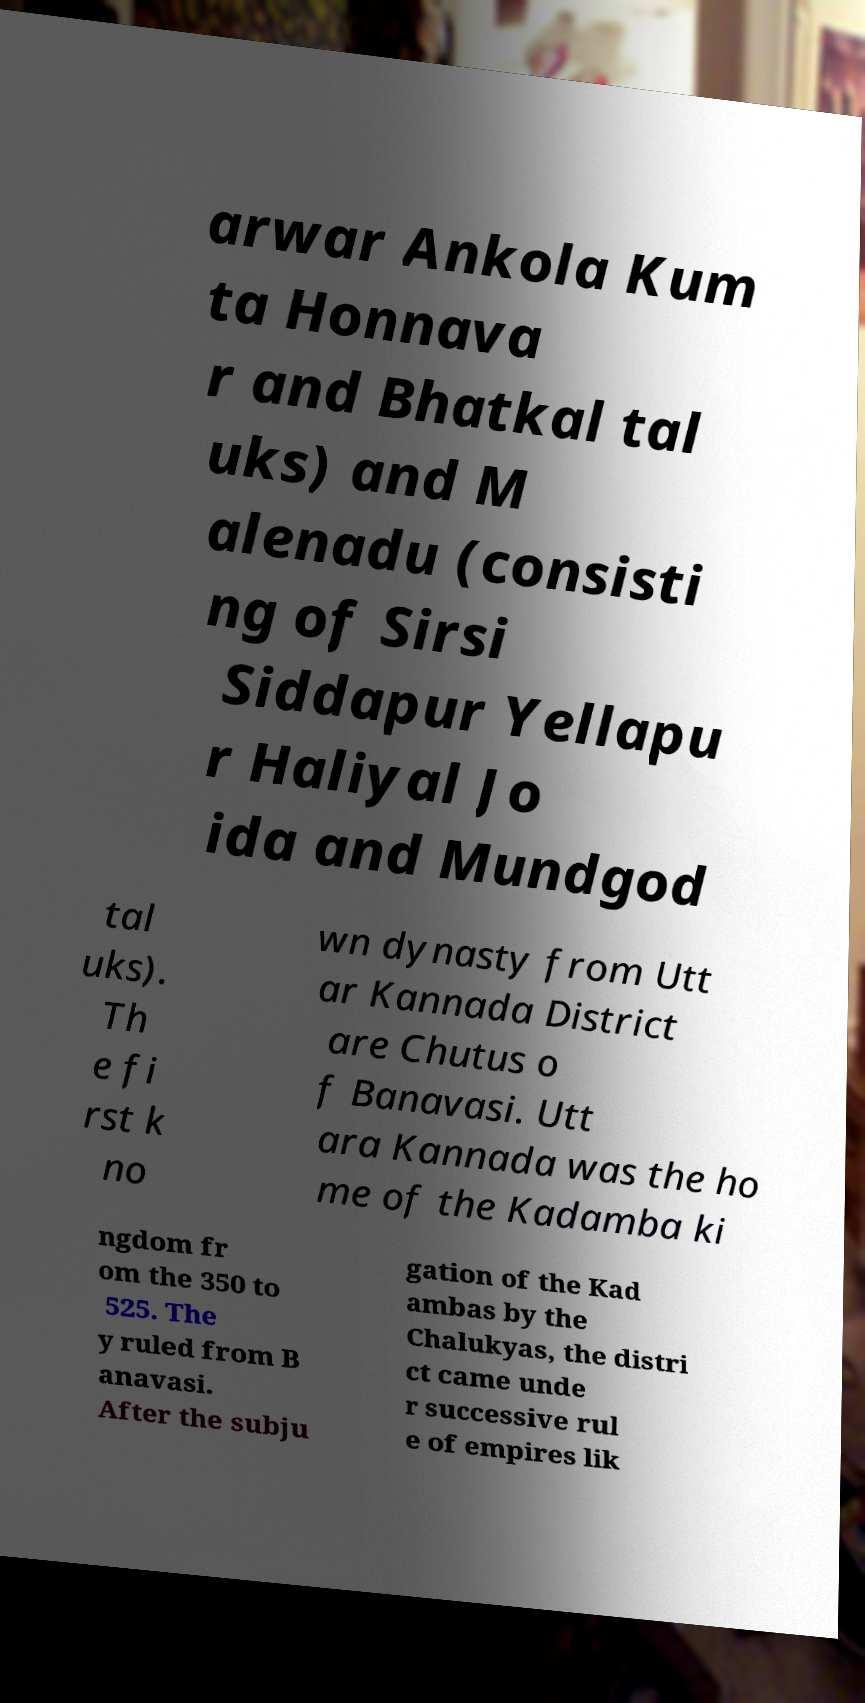Can you read and provide the text displayed in the image?This photo seems to have some interesting text. Can you extract and type it out for me? arwar Ankola Kum ta Honnava r and Bhatkal tal uks) and M alenadu (consisti ng of Sirsi Siddapur Yellapu r Haliyal Jo ida and Mundgod tal uks). Th e fi rst k no wn dynasty from Utt ar Kannada District are Chutus o f Banavasi. Utt ara Kannada was the ho me of the Kadamba ki ngdom fr om the 350 to 525. The y ruled from B anavasi. After the subju gation of the Kad ambas by the Chalukyas, the distri ct came unde r successive rul e of empires lik 